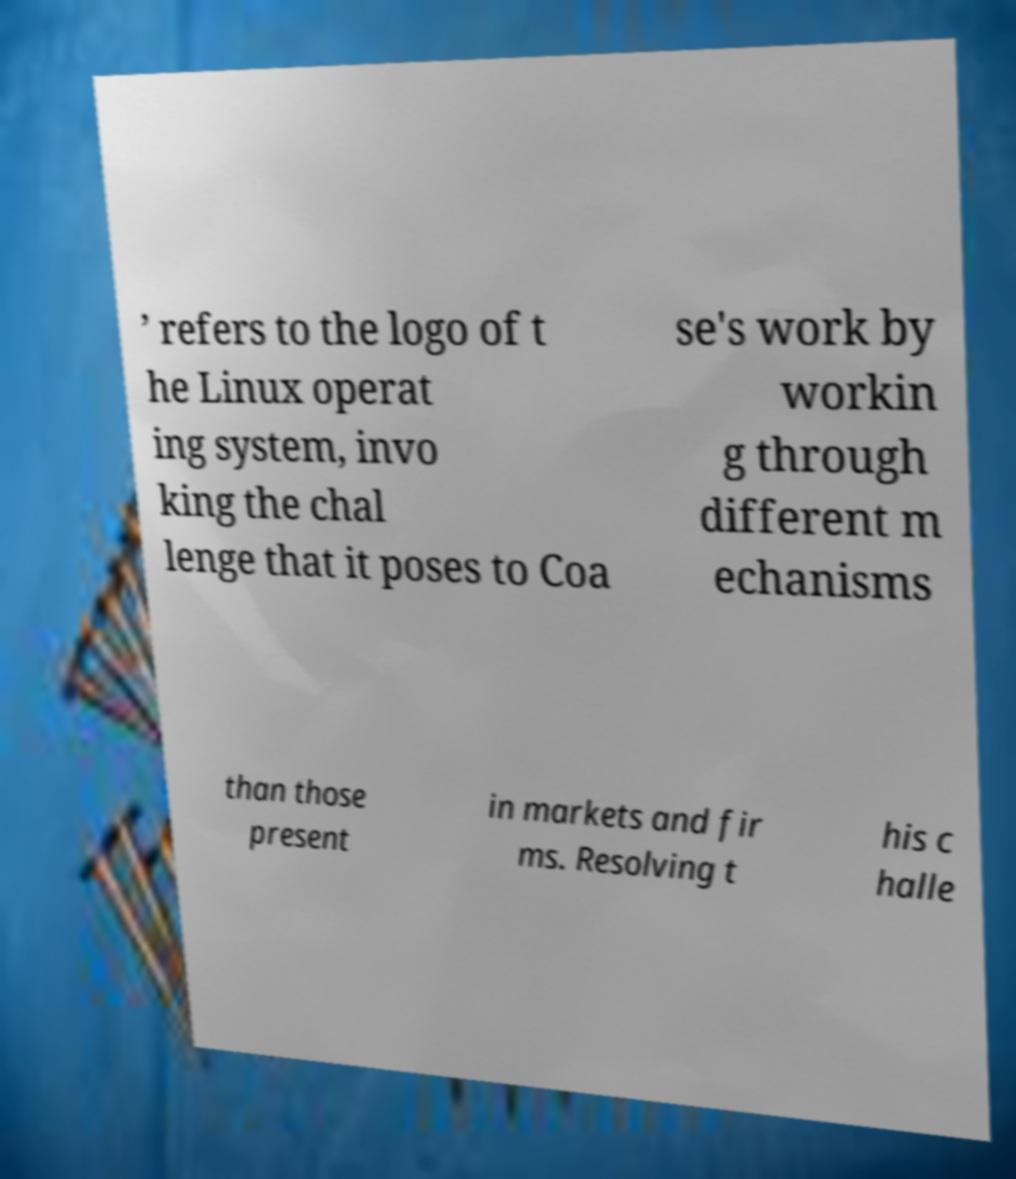Can you read and provide the text displayed in the image?This photo seems to have some interesting text. Can you extract and type it out for me? ’ refers to the logo of t he Linux operat ing system, invo king the chal lenge that it poses to Coa se's work by workin g through different m echanisms than those present in markets and fir ms. Resolving t his c halle 